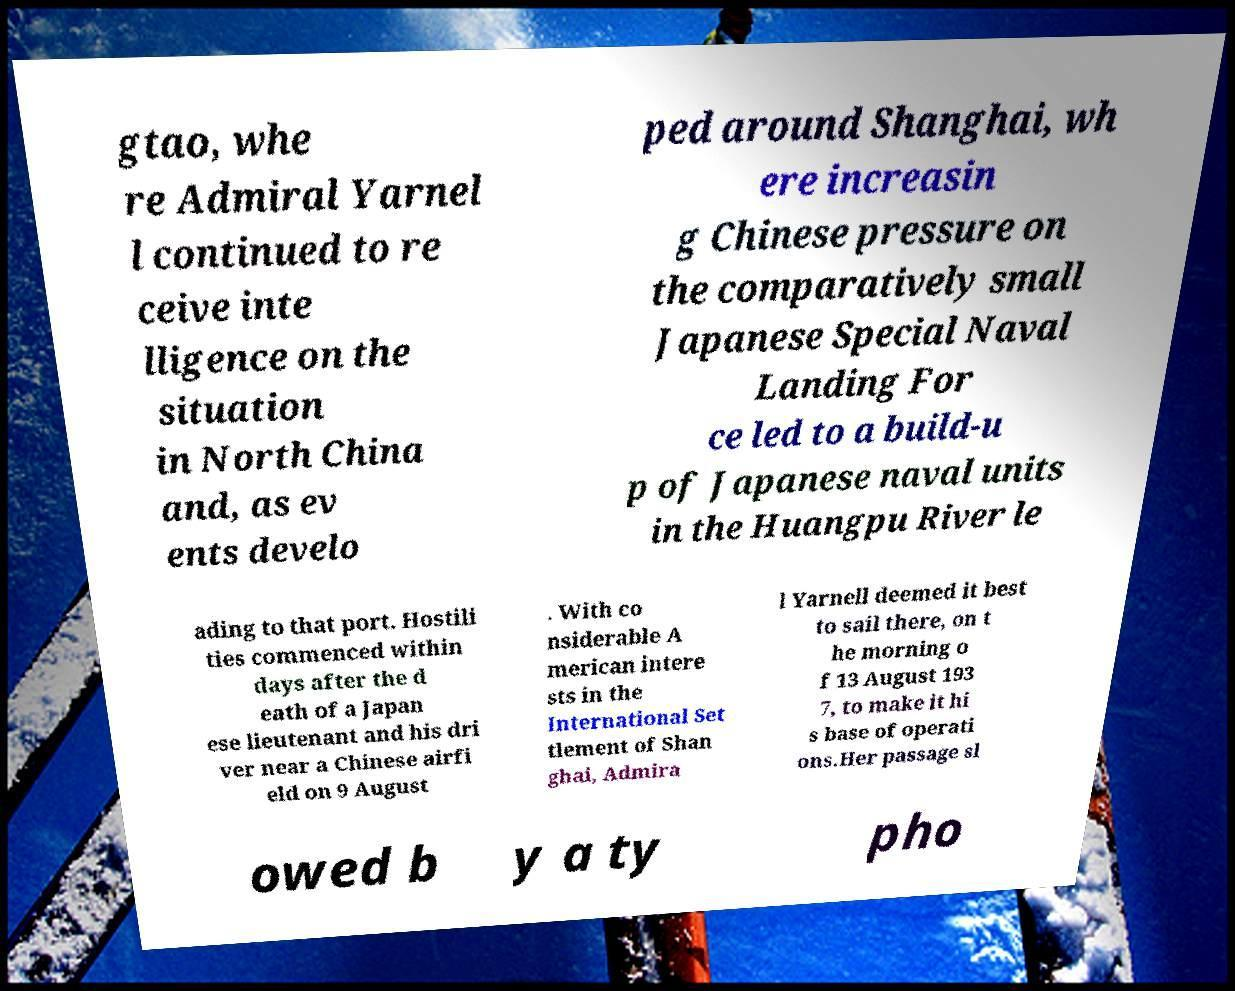I need the written content from this picture converted into text. Can you do that? gtao, whe re Admiral Yarnel l continued to re ceive inte lligence on the situation in North China and, as ev ents develo ped around Shanghai, wh ere increasin g Chinese pressure on the comparatively small Japanese Special Naval Landing For ce led to a build-u p of Japanese naval units in the Huangpu River le ading to that port. Hostili ties commenced within days after the d eath of a Japan ese lieutenant and his dri ver near a Chinese airfi eld on 9 August . With co nsiderable A merican intere sts in the International Set tlement of Shan ghai, Admira l Yarnell deemed it best to sail there, on t he morning o f 13 August 193 7, to make it hi s base of operati ons.Her passage sl owed b y a ty pho 